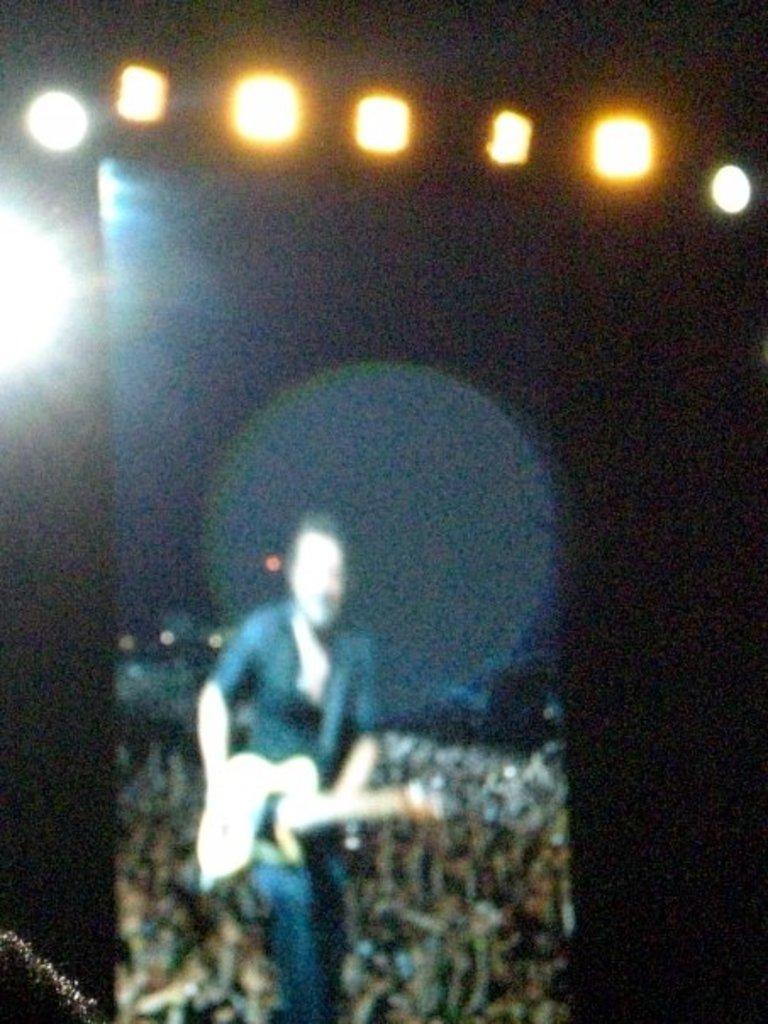In one or two sentences, can you explain what this image depicts? In this image we can see a man. He is holding a guitar in his hand. Behind him, a crowd of people is there. At the top of the image, we can see the lights. 